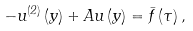<formula> <loc_0><loc_0><loc_500><loc_500>- u ^ { \left ( 2 \right ) } \left ( y \right ) + A u \left ( y \right ) = \bar { f } \left ( \tau \right ) ,</formula> 